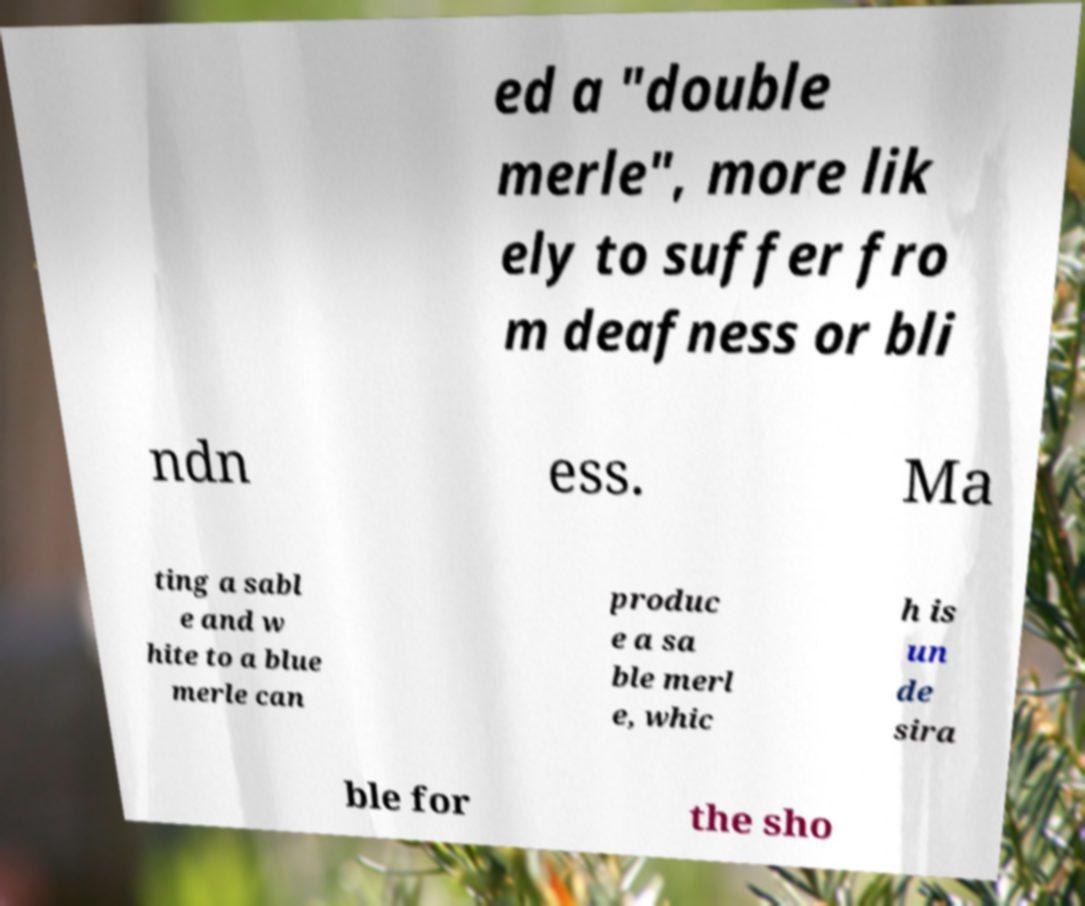Could you extract and type out the text from this image? ed a "double merle", more lik ely to suffer fro m deafness or bli ndn ess. Ma ting a sabl e and w hite to a blue merle can produc e a sa ble merl e, whic h is un de sira ble for the sho 